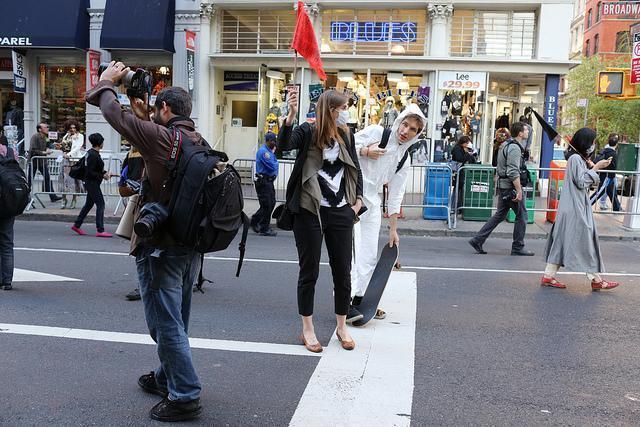How many people are there?
Give a very brief answer. 7. 